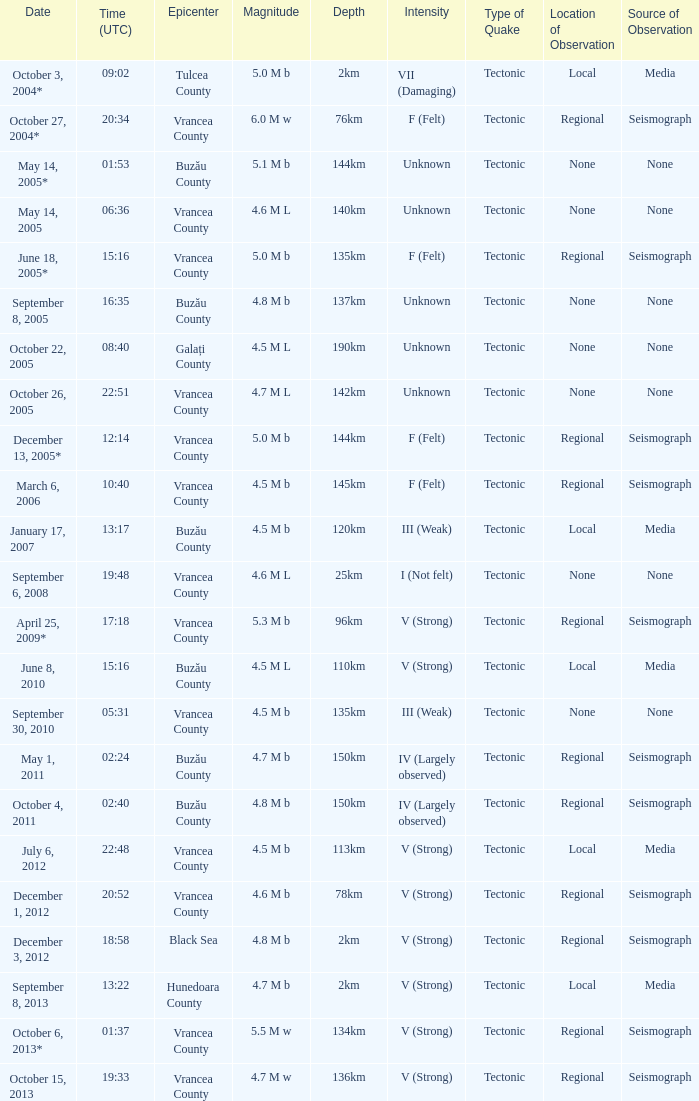Where was the epicenter of the quake on December 1, 2012? Vrancea County. 